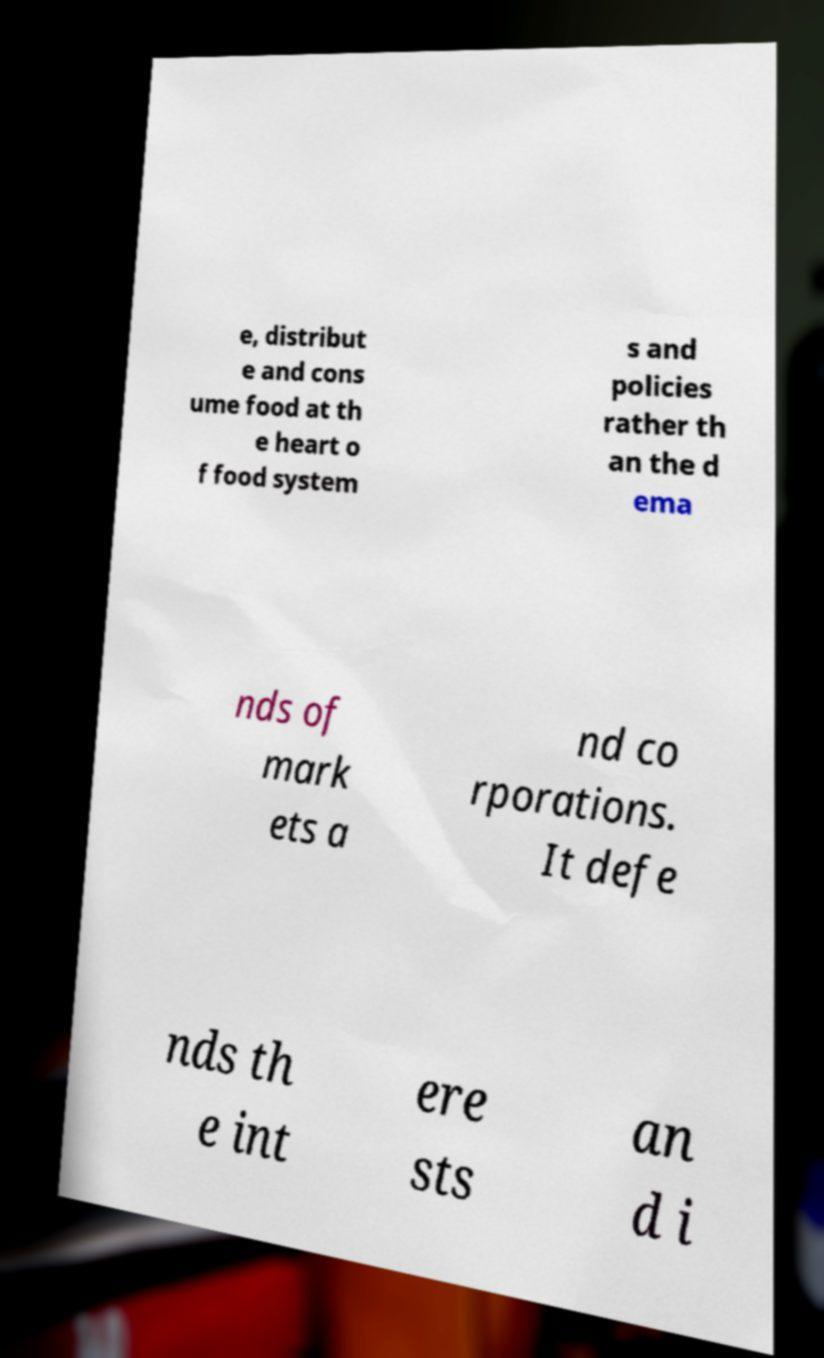Please read and relay the text visible in this image. What does it say? e, distribut e and cons ume food at th e heart o f food system s and policies rather th an the d ema nds of mark ets a nd co rporations. It defe nds th e int ere sts an d i 